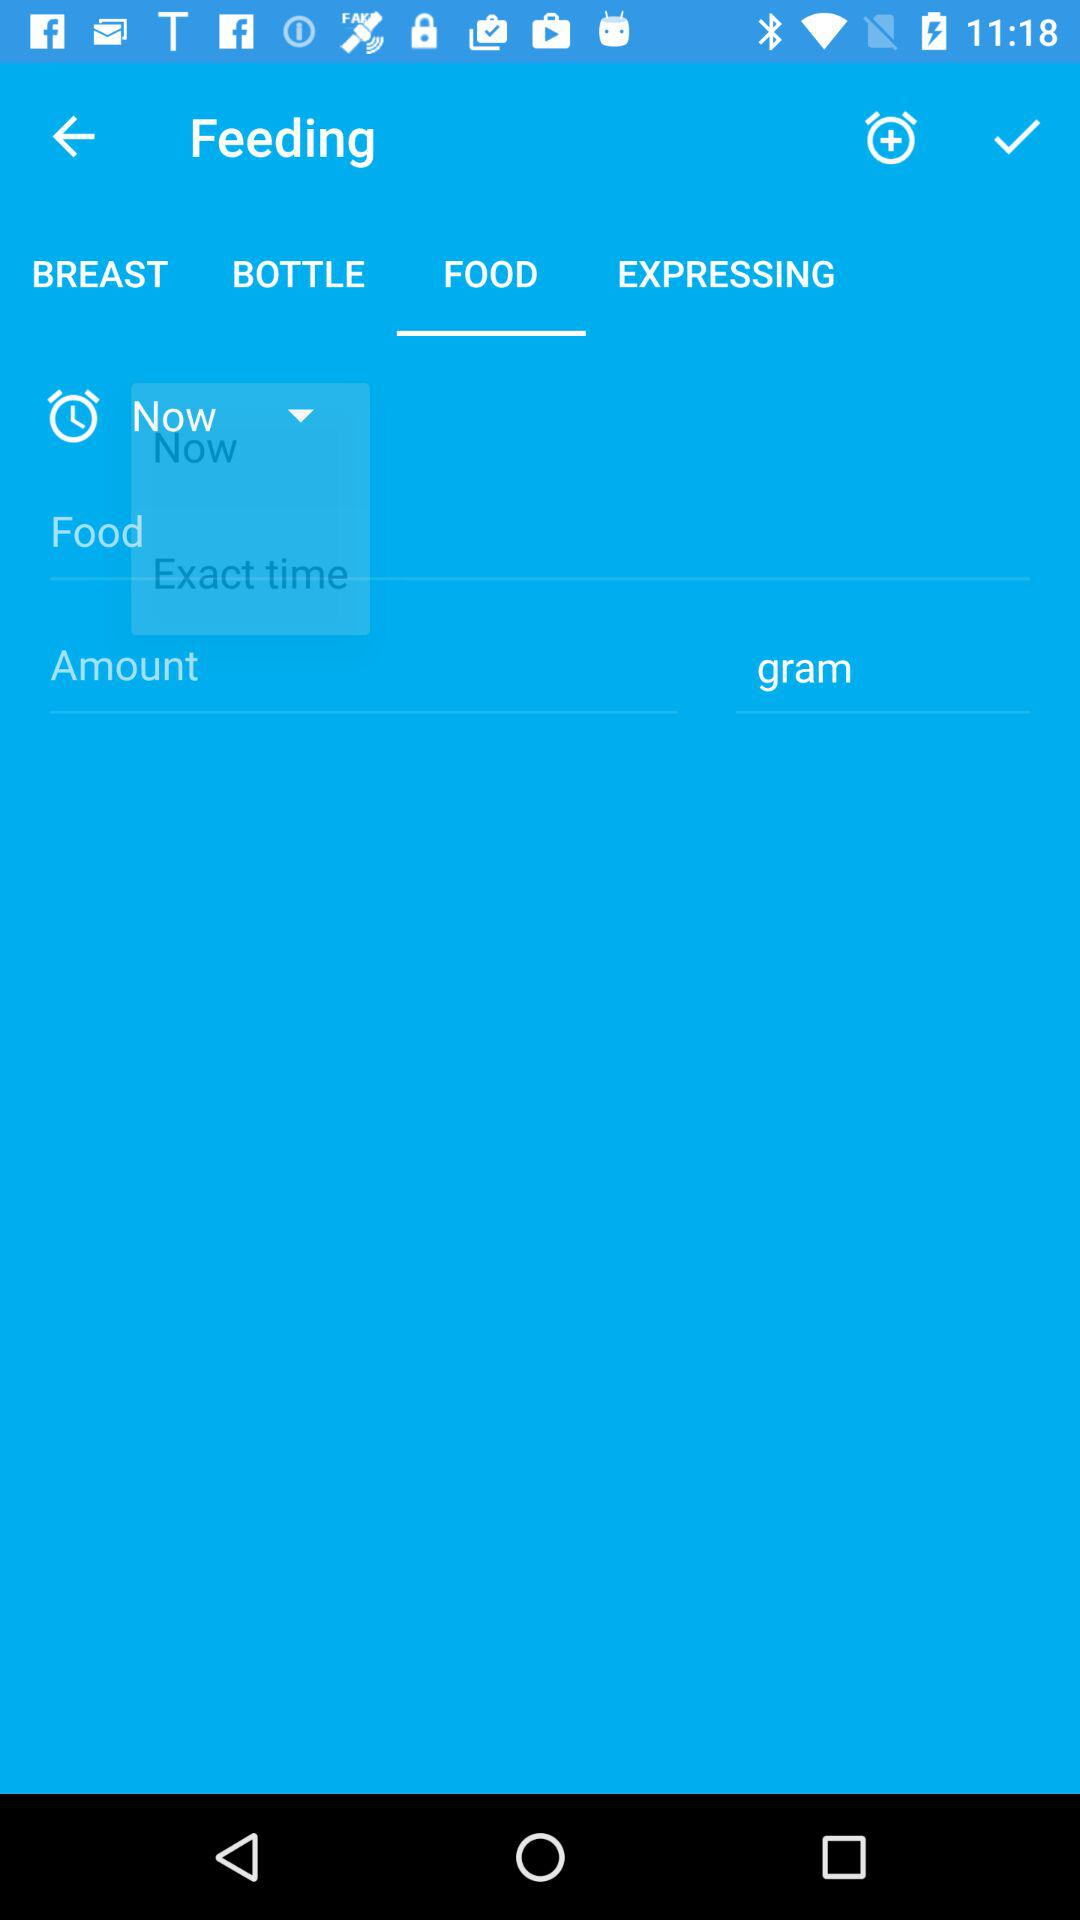Which category of feeding am I in? You are in the "FOOD" category. 